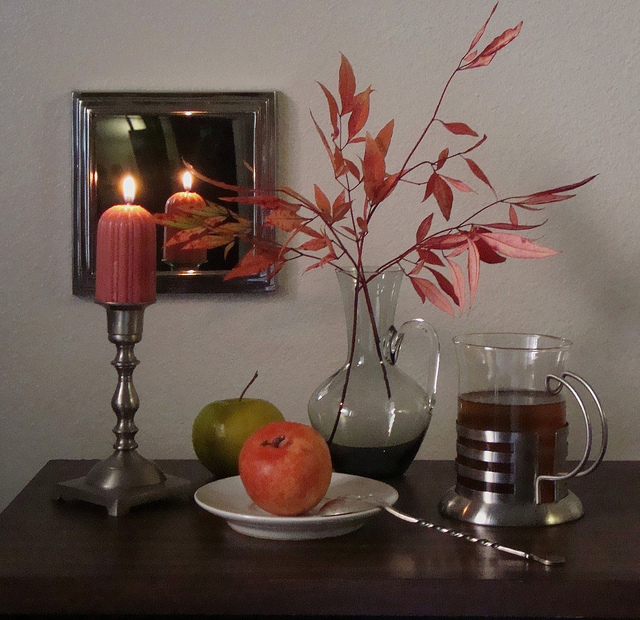<image>What is the color of the flower? I am not sure what the color of the flower is. It can be seen as pink, orange or red. However, there might be no flower in the image. What is the color of the flower? The flower in the image is red in color. 